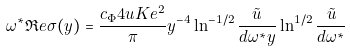Convert formula to latex. <formula><loc_0><loc_0><loc_500><loc_500>\omega ^ { * } \Re e \sigma ( y ) = \frac { c _ { \Phi } 4 u K e ^ { 2 } } { \pi } y ^ { - 4 } \ln ^ { - 1 / 2 } \frac { \tilde { u } } { d \omega ^ { * } y } \ln ^ { 1 / 2 } \frac { \tilde { u } } { d \omega ^ { * } }</formula> 